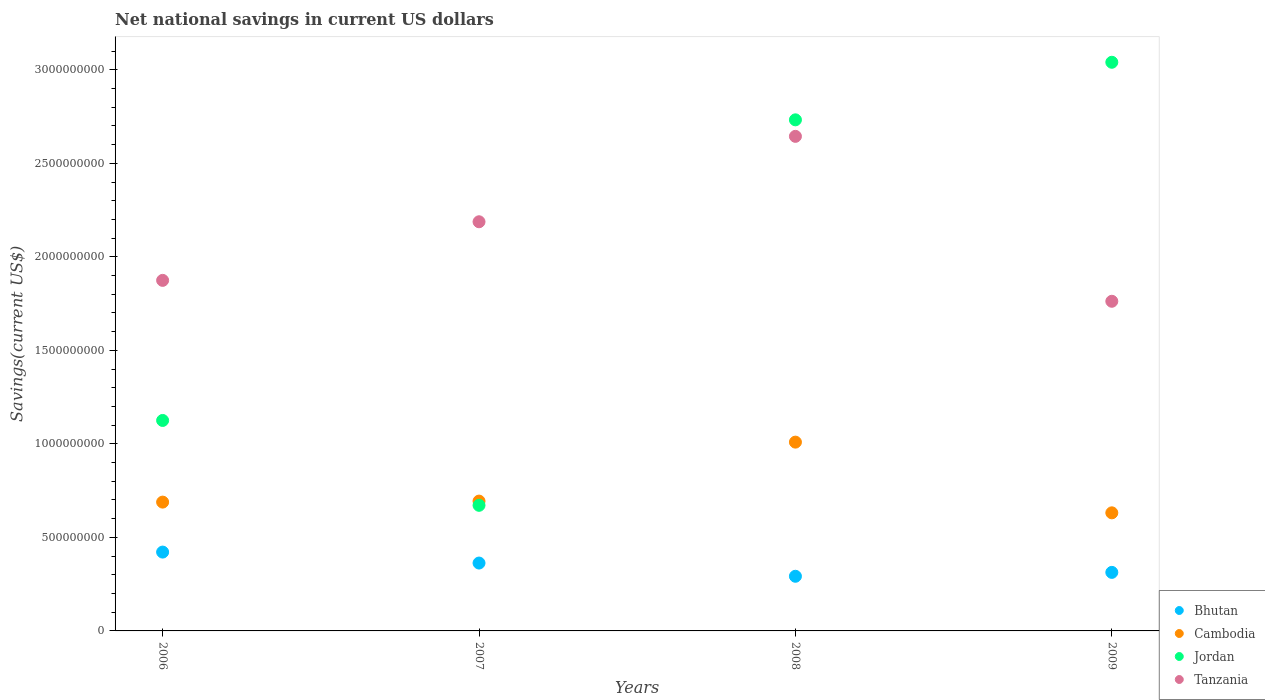Is the number of dotlines equal to the number of legend labels?
Your answer should be very brief. Yes. What is the net national savings in Cambodia in 2009?
Your answer should be very brief. 6.31e+08. Across all years, what is the maximum net national savings in Cambodia?
Provide a succinct answer. 1.01e+09. Across all years, what is the minimum net national savings in Tanzania?
Provide a short and direct response. 1.76e+09. In which year was the net national savings in Jordan minimum?
Make the answer very short. 2007. What is the total net national savings in Cambodia in the graph?
Offer a very short reply. 3.02e+09. What is the difference between the net national savings in Tanzania in 2006 and that in 2007?
Offer a terse response. -3.13e+08. What is the difference between the net national savings in Cambodia in 2006 and the net national savings in Bhutan in 2008?
Ensure brevity in your answer.  3.96e+08. What is the average net national savings in Bhutan per year?
Ensure brevity in your answer.  3.47e+08. In the year 2006, what is the difference between the net national savings in Bhutan and net national savings in Cambodia?
Your answer should be compact. -2.67e+08. In how many years, is the net national savings in Tanzania greater than 2800000000 US$?
Your answer should be very brief. 0. What is the ratio of the net national savings in Bhutan in 2006 to that in 2008?
Offer a terse response. 1.44. Is the net national savings in Bhutan in 2006 less than that in 2009?
Provide a succinct answer. No. Is the difference between the net national savings in Bhutan in 2006 and 2009 greater than the difference between the net national savings in Cambodia in 2006 and 2009?
Keep it short and to the point. Yes. What is the difference between the highest and the second highest net national savings in Bhutan?
Your answer should be compact. 5.86e+07. What is the difference between the highest and the lowest net national savings in Cambodia?
Keep it short and to the point. 3.78e+08. In how many years, is the net national savings in Cambodia greater than the average net national savings in Cambodia taken over all years?
Give a very brief answer. 1. Is the sum of the net national savings in Cambodia in 2007 and 2008 greater than the maximum net national savings in Bhutan across all years?
Your response must be concise. Yes. Is it the case that in every year, the sum of the net national savings in Jordan and net national savings in Cambodia  is greater than the sum of net national savings in Tanzania and net national savings in Bhutan?
Offer a terse response. Yes. Is it the case that in every year, the sum of the net national savings in Cambodia and net national savings in Tanzania  is greater than the net national savings in Bhutan?
Your answer should be compact. Yes. Does the net national savings in Jordan monotonically increase over the years?
Provide a succinct answer. No. Is the net national savings in Bhutan strictly less than the net national savings in Cambodia over the years?
Provide a short and direct response. Yes. How many dotlines are there?
Your response must be concise. 4. Does the graph contain any zero values?
Your response must be concise. No. Where does the legend appear in the graph?
Give a very brief answer. Bottom right. How are the legend labels stacked?
Your answer should be very brief. Vertical. What is the title of the graph?
Keep it short and to the point. Net national savings in current US dollars. Does "Bulgaria" appear as one of the legend labels in the graph?
Provide a succinct answer. No. What is the label or title of the X-axis?
Make the answer very short. Years. What is the label or title of the Y-axis?
Give a very brief answer. Savings(current US$). What is the Savings(current US$) of Bhutan in 2006?
Your response must be concise. 4.21e+08. What is the Savings(current US$) in Cambodia in 2006?
Give a very brief answer. 6.89e+08. What is the Savings(current US$) in Jordan in 2006?
Provide a short and direct response. 1.13e+09. What is the Savings(current US$) in Tanzania in 2006?
Offer a very short reply. 1.87e+09. What is the Savings(current US$) of Bhutan in 2007?
Keep it short and to the point. 3.63e+08. What is the Savings(current US$) of Cambodia in 2007?
Ensure brevity in your answer.  6.94e+08. What is the Savings(current US$) of Jordan in 2007?
Give a very brief answer. 6.72e+08. What is the Savings(current US$) in Tanzania in 2007?
Provide a succinct answer. 2.19e+09. What is the Savings(current US$) of Bhutan in 2008?
Keep it short and to the point. 2.92e+08. What is the Savings(current US$) in Cambodia in 2008?
Your answer should be compact. 1.01e+09. What is the Savings(current US$) in Jordan in 2008?
Your response must be concise. 2.73e+09. What is the Savings(current US$) in Tanzania in 2008?
Offer a terse response. 2.64e+09. What is the Savings(current US$) of Bhutan in 2009?
Make the answer very short. 3.13e+08. What is the Savings(current US$) of Cambodia in 2009?
Your response must be concise. 6.31e+08. What is the Savings(current US$) in Jordan in 2009?
Ensure brevity in your answer.  3.04e+09. What is the Savings(current US$) in Tanzania in 2009?
Make the answer very short. 1.76e+09. Across all years, what is the maximum Savings(current US$) in Bhutan?
Offer a very short reply. 4.21e+08. Across all years, what is the maximum Savings(current US$) of Cambodia?
Your answer should be compact. 1.01e+09. Across all years, what is the maximum Savings(current US$) in Jordan?
Make the answer very short. 3.04e+09. Across all years, what is the maximum Savings(current US$) in Tanzania?
Give a very brief answer. 2.64e+09. Across all years, what is the minimum Savings(current US$) in Bhutan?
Offer a terse response. 2.92e+08. Across all years, what is the minimum Savings(current US$) of Cambodia?
Give a very brief answer. 6.31e+08. Across all years, what is the minimum Savings(current US$) in Jordan?
Ensure brevity in your answer.  6.72e+08. Across all years, what is the minimum Savings(current US$) in Tanzania?
Provide a succinct answer. 1.76e+09. What is the total Savings(current US$) in Bhutan in the graph?
Offer a terse response. 1.39e+09. What is the total Savings(current US$) in Cambodia in the graph?
Offer a very short reply. 3.02e+09. What is the total Savings(current US$) of Jordan in the graph?
Offer a terse response. 7.57e+09. What is the total Savings(current US$) of Tanzania in the graph?
Offer a very short reply. 8.47e+09. What is the difference between the Savings(current US$) in Bhutan in 2006 and that in 2007?
Your answer should be very brief. 5.86e+07. What is the difference between the Savings(current US$) of Cambodia in 2006 and that in 2007?
Offer a very short reply. -5.39e+06. What is the difference between the Savings(current US$) of Jordan in 2006 and that in 2007?
Make the answer very short. 4.54e+08. What is the difference between the Savings(current US$) in Tanzania in 2006 and that in 2007?
Offer a terse response. -3.13e+08. What is the difference between the Savings(current US$) of Bhutan in 2006 and that in 2008?
Make the answer very short. 1.29e+08. What is the difference between the Savings(current US$) of Cambodia in 2006 and that in 2008?
Your answer should be very brief. -3.21e+08. What is the difference between the Savings(current US$) in Jordan in 2006 and that in 2008?
Ensure brevity in your answer.  -1.61e+09. What is the difference between the Savings(current US$) of Tanzania in 2006 and that in 2008?
Provide a short and direct response. -7.70e+08. What is the difference between the Savings(current US$) in Bhutan in 2006 and that in 2009?
Your answer should be very brief. 1.08e+08. What is the difference between the Savings(current US$) of Cambodia in 2006 and that in 2009?
Offer a terse response. 5.73e+07. What is the difference between the Savings(current US$) of Jordan in 2006 and that in 2009?
Provide a succinct answer. -1.91e+09. What is the difference between the Savings(current US$) of Tanzania in 2006 and that in 2009?
Your answer should be very brief. 1.12e+08. What is the difference between the Savings(current US$) of Bhutan in 2007 and that in 2008?
Offer a very short reply. 7.07e+07. What is the difference between the Savings(current US$) of Cambodia in 2007 and that in 2008?
Offer a terse response. -3.15e+08. What is the difference between the Savings(current US$) of Jordan in 2007 and that in 2008?
Provide a short and direct response. -2.06e+09. What is the difference between the Savings(current US$) in Tanzania in 2007 and that in 2008?
Keep it short and to the point. -4.57e+08. What is the difference between the Savings(current US$) of Bhutan in 2007 and that in 2009?
Your answer should be very brief. 4.99e+07. What is the difference between the Savings(current US$) of Cambodia in 2007 and that in 2009?
Your answer should be compact. 6.27e+07. What is the difference between the Savings(current US$) of Jordan in 2007 and that in 2009?
Your answer should be compact. -2.37e+09. What is the difference between the Savings(current US$) of Tanzania in 2007 and that in 2009?
Your answer should be compact. 4.25e+08. What is the difference between the Savings(current US$) of Bhutan in 2008 and that in 2009?
Your answer should be compact. -2.08e+07. What is the difference between the Savings(current US$) in Cambodia in 2008 and that in 2009?
Offer a very short reply. 3.78e+08. What is the difference between the Savings(current US$) of Jordan in 2008 and that in 2009?
Provide a succinct answer. -3.08e+08. What is the difference between the Savings(current US$) in Tanzania in 2008 and that in 2009?
Provide a short and direct response. 8.82e+08. What is the difference between the Savings(current US$) of Bhutan in 2006 and the Savings(current US$) of Cambodia in 2007?
Provide a succinct answer. -2.73e+08. What is the difference between the Savings(current US$) in Bhutan in 2006 and the Savings(current US$) in Jordan in 2007?
Make the answer very short. -2.50e+08. What is the difference between the Savings(current US$) in Bhutan in 2006 and the Savings(current US$) in Tanzania in 2007?
Make the answer very short. -1.77e+09. What is the difference between the Savings(current US$) in Cambodia in 2006 and the Savings(current US$) in Jordan in 2007?
Make the answer very short. 1.71e+07. What is the difference between the Savings(current US$) of Cambodia in 2006 and the Savings(current US$) of Tanzania in 2007?
Make the answer very short. -1.50e+09. What is the difference between the Savings(current US$) in Jordan in 2006 and the Savings(current US$) in Tanzania in 2007?
Offer a very short reply. -1.06e+09. What is the difference between the Savings(current US$) of Bhutan in 2006 and the Savings(current US$) of Cambodia in 2008?
Your answer should be compact. -5.88e+08. What is the difference between the Savings(current US$) in Bhutan in 2006 and the Savings(current US$) in Jordan in 2008?
Offer a terse response. -2.31e+09. What is the difference between the Savings(current US$) in Bhutan in 2006 and the Savings(current US$) in Tanzania in 2008?
Provide a short and direct response. -2.22e+09. What is the difference between the Savings(current US$) of Cambodia in 2006 and the Savings(current US$) of Jordan in 2008?
Your answer should be very brief. -2.04e+09. What is the difference between the Savings(current US$) in Cambodia in 2006 and the Savings(current US$) in Tanzania in 2008?
Make the answer very short. -1.96e+09. What is the difference between the Savings(current US$) in Jordan in 2006 and the Savings(current US$) in Tanzania in 2008?
Provide a succinct answer. -1.52e+09. What is the difference between the Savings(current US$) of Bhutan in 2006 and the Savings(current US$) of Cambodia in 2009?
Make the answer very short. -2.10e+08. What is the difference between the Savings(current US$) in Bhutan in 2006 and the Savings(current US$) in Jordan in 2009?
Provide a short and direct response. -2.62e+09. What is the difference between the Savings(current US$) in Bhutan in 2006 and the Savings(current US$) in Tanzania in 2009?
Ensure brevity in your answer.  -1.34e+09. What is the difference between the Savings(current US$) in Cambodia in 2006 and the Savings(current US$) in Jordan in 2009?
Your answer should be very brief. -2.35e+09. What is the difference between the Savings(current US$) of Cambodia in 2006 and the Savings(current US$) of Tanzania in 2009?
Ensure brevity in your answer.  -1.07e+09. What is the difference between the Savings(current US$) of Jordan in 2006 and the Savings(current US$) of Tanzania in 2009?
Make the answer very short. -6.37e+08. What is the difference between the Savings(current US$) in Bhutan in 2007 and the Savings(current US$) in Cambodia in 2008?
Your answer should be very brief. -6.46e+08. What is the difference between the Savings(current US$) of Bhutan in 2007 and the Savings(current US$) of Jordan in 2008?
Offer a terse response. -2.37e+09. What is the difference between the Savings(current US$) in Bhutan in 2007 and the Savings(current US$) in Tanzania in 2008?
Offer a terse response. -2.28e+09. What is the difference between the Savings(current US$) of Cambodia in 2007 and the Savings(current US$) of Jordan in 2008?
Offer a terse response. -2.04e+09. What is the difference between the Savings(current US$) in Cambodia in 2007 and the Savings(current US$) in Tanzania in 2008?
Ensure brevity in your answer.  -1.95e+09. What is the difference between the Savings(current US$) of Jordan in 2007 and the Savings(current US$) of Tanzania in 2008?
Your response must be concise. -1.97e+09. What is the difference between the Savings(current US$) of Bhutan in 2007 and the Savings(current US$) of Cambodia in 2009?
Offer a very short reply. -2.68e+08. What is the difference between the Savings(current US$) of Bhutan in 2007 and the Savings(current US$) of Jordan in 2009?
Provide a succinct answer. -2.68e+09. What is the difference between the Savings(current US$) of Bhutan in 2007 and the Savings(current US$) of Tanzania in 2009?
Your answer should be compact. -1.40e+09. What is the difference between the Savings(current US$) in Cambodia in 2007 and the Savings(current US$) in Jordan in 2009?
Provide a short and direct response. -2.35e+09. What is the difference between the Savings(current US$) of Cambodia in 2007 and the Savings(current US$) of Tanzania in 2009?
Provide a succinct answer. -1.07e+09. What is the difference between the Savings(current US$) of Jordan in 2007 and the Savings(current US$) of Tanzania in 2009?
Give a very brief answer. -1.09e+09. What is the difference between the Savings(current US$) of Bhutan in 2008 and the Savings(current US$) of Cambodia in 2009?
Make the answer very short. -3.39e+08. What is the difference between the Savings(current US$) in Bhutan in 2008 and the Savings(current US$) in Jordan in 2009?
Offer a terse response. -2.75e+09. What is the difference between the Savings(current US$) of Bhutan in 2008 and the Savings(current US$) of Tanzania in 2009?
Your response must be concise. -1.47e+09. What is the difference between the Savings(current US$) of Cambodia in 2008 and the Savings(current US$) of Jordan in 2009?
Your response must be concise. -2.03e+09. What is the difference between the Savings(current US$) of Cambodia in 2008 and the Savings(current US$) of Tanzania in 2009?
Your response must be concise. -7.53e+08. What is the difference between the Savings(current US$) of Jordan in 2008 and the Savings(current US$) of Tanzania in 2009?
Make the answer very short. 9.70e+08. What is the average Savings(current US$) in Bhutan per year?
Keep it short and to the point. 3.47e+08. What is the average Savings(current US$) of Cambodia per year?
Offer a very short reply. 7.56e+08. What is the average Savings(current US$) of Jordan per year?
Provide a succinct answer. 1.89e+09. What is the average Savings(current US$) in Tanzania per year?
Your answer should be compact. 2.12e+09. In the year 2006, what is the difference between the Savings(current US$) of Bhutan and Savings(current US$) of Cambodia?
Offer a terse response. -2.67e+08. In the year 2006, what is the difference between the Savings(current US$) in Bhutan and Savings(current US$) in Jordan?
Ensure brevity in your answer.  -7.04e+08. In the year 2006, what is the difference between the Savings(current US$) in Bhutan and Savings(current US$) in Tanzania?
Make the answer very short. -1.45e+09. In the year 2006, what is the difference between the Savings(current US$) in Cambodia and Savings(current US$) in Jordan?
Ensure brevity in your answer.  -4.37e+08. In the year 2006, what is the difference between the Savings(current US$) of Cambodia and Savings(current US$) of Tanzania?
Provide a short and direct response. -1.19e+09. In the year 2006, what is the difference between the Savings(current US$) of Jordan and Savings(current US$) of Tanzania?
Your answer should be compact. -7.49e+08. In the year 2007, what is the difference between the Savings(current US$) in Bhutan and Savings(current US$) in Cambodia?
Ensure brevity in your answer.  -3.31e+08. In the year 2007, what is the difference between the Savings(current US$) in Bhutan and Savings(current US$) in Jordan?
Provide a short and direct response. -3.09e+08. In the year 2007, what is the difference between the Savings(current US$) of Bhutan and Savings(current US$) of Tanzania?
Offer a terse response. -1.82e+09. In the year 2007, what is the difference between the Savings(current US$) of Cambodia and Savings(current US$) of Jordan?
Your answer should be very brief. 2.25e+07. In the year 2007, what is the difference between the Savings(current US$) in Cambodia and Savings(current US$) in Tanzania?
Provide a short and direct response. -1.49e+09. In the year 2007, what is the difference between the Savings(current US$) of Jordan and Savings(current US$) of Tanzania?
Make the answer very short. -1.52e+09. In the year 2008, what is the difference between the Savings(current US$) of Bhutan and Savings(current US$) of Cambodia?
Your answer should be compact. -7.17e+08. In the year 2008, what is the difference between the Savings(current US$) in Bhutan and Savings(current US$) in Jordan?
Your response must be concise. -2.44e+09. In the year 2008, what is the difference between the Savings(current US$) of Bhutan and Savings(current US$) of Tanzania?
Make the answer very short. -2.35e+09. In the year 2008, what is the difference between the Savings(current US$) of Cambodia and Savings(current US$) of Jordan?
Your answer should be very brief. -1.72e+09. In the year 2008, what is the difference between the Savings(current US$) of Cambodia and Savings(current US$) of Tanzania?
Offer a very short reply. -1.63e+09. In the year 2008, what is the difference between the Savings(current US$) in Jordan and Savings(current US$) in Tanzania?
Ensure brevity in your answer.  8.83e+07. In the year 2009, what is the difference between the Savings(current US$) of Bhutan and Savings(current US$) of Cambodia?
Your answer should be compact. -3.18e+08. In the year 2009, what is the difference between the Savings(current US$) in Bhutan and Savings(current US$) in Jordan?
Offer a very short reply. -2.73e+09. In the year 2009, what is the difference between the Savings(current US$) in Bhutan and Savings(current US$) in Tanzania?
Your answer should be compact. -1.45e+09. In the year 2009, what is the difference between the Savings(current US$) in Cambodia and Savings(current US$) in Jordan?
Keep it short and to the point. -2.41e+09. In the year 2009, what is the difference between the Savings(current US$) in Cambodia and Savings(current US$) in Tanzania?
Give a very brief answer. -1.13e+09. In the year 2009, what is the difference between the Savings(current US$) of Jordan and Savings(current US$) of Tanzania?
Your answer should be compact. 1.28e+09. What is the ratio of the Savings(current US$) of Bhutan in 2006 to that in 2007?
Your response must be concise. 1.16. What is the ratio of the Savings(current US$) in Cambodia in 2006 to that in 2007?
Give a very brief answer. 0.99. What is the ratio of the Savings(current US$) of Jordan in 2006 to that in 2007?
Provide a succinct answer. 1.68. What is the ratio of the Savings(current US$) of Tanzania in 2006 to that in 2007?
Provide a short and direct response. 0.86. What is the ratio of the Savings(current US$) in Bhutan in 2006 to that in 2008?
Ensure brevity in your answer.  1.44. What is the ratio of the Savings(current US$) of Cambodia in 2006 to that in 2008?
Your response must be concise. 0.68. What is the ratio of the Savings(current US$) of Jordan in 2006 to that in 2008?
Ensure brevity in your answer.  0.41. What is the ratio of the Savings(current US$) in Tanzania in 2006 to that in 2008?
Give a very brief answer. 0.71. What is the ratio of the Savings(current US$) of Bhutan in 2006 to that in 2009?
Give a very brief answer. 1.35. What is the ratio of the Savings(current US$) in Cambodia in 2006 to that in 2009?
Ensure brevity in your answer.  1.09. What is the ratio of the Savings(current US$) of Jordan in 2006 to that in 2009?
Your response must be concise. 0.37. What is the ratio of the Savings(current US$) of Tanzania in 2006 to that in 2009?
Provide a succinct answer. 1.06. What is the ratio of the Savings(current US$) of Bhutan in 2007 to that in 2008?
Ensure brevity in your answer.  1.24. What is the ratio of the Savings(current US$) in Cambodia in 2007 to that in 2008?
Give a very brief answer. 0.69. What is the ratio of the Savings(current US$) of Jordan in 2007 to that in 2008?
Offer a very short reply. 0.25. What is the ratio of the Savings(current US$) in Tanzania in 2007 to that in 2008?
Give a very brief answer. 0.83. What is the ratio of the Savings(current US$) in Bhutan in 2007 to that in 2009?
Provide a succinct answer. 1.16. What is the ratio of the Savings(current US$) of Cambodia in 2007 to that in 2009?
Your response must be concise. 1.1. What is the ratio of the Savings(current US$) in Jordan in 2007 to that in 2009?
Offer a very short reply. 0.22. What is the ratio of the Savings(current US$) in Tanzania in 2007 to that in 2009?
Provide a short and direct response. 1.24. What is the ratio of the Savings(current US$) in Bhutan in 2008 to that in 2009?
Offer a very short reply. 0.93. What is the ratio of the Savings(current US$) in Cambodia in 2008 to that in 2009?
Provide a succinct answer. 1.6. What is the ratio of the Savings(current US$) of Jordan in 2008 to that in 2009?
Your answer should be very brief. 0.9. What is the ratio of the Savings(current US$) in Tanzania in 2008 to that in 2009?
Your response must be concise. 1.5. What is the difference between the highest and the second highest Savings(current US$) of Bhutan?
Your answer should be very brief. 5.86e+07. What is the difference between the highest and the second highest Savings(current US$) of Cambodia?
Ensure brevity in your answer.  3.15e+08. What is the difference between the highest and the second highest Savings(current US$) in Jordan?
Ensure brevity in your answer.  3.08e+08. What is the difference between the highest and the second highest Savings(current US$) in Tanzania?
Offer a terse response. 4.57e+08. What is the difference between the highest and the lowest Savings(current US$) of Bhutan?
Offer a very short reply. 1.29e+08. What is the difference between the highest and the lowest Savings(current US$) of Cambodia?
Provide a short and direct response. 3.78e+08. What is the difference between the highest and the lowest Savings(current US$) of Jordan?
Keep it short and to the point. 2.37e+09. What is the difference between the highest and the lowest Savings(current US$) in Tanzania?
Keep it short and to the point. 8.82e+08. 